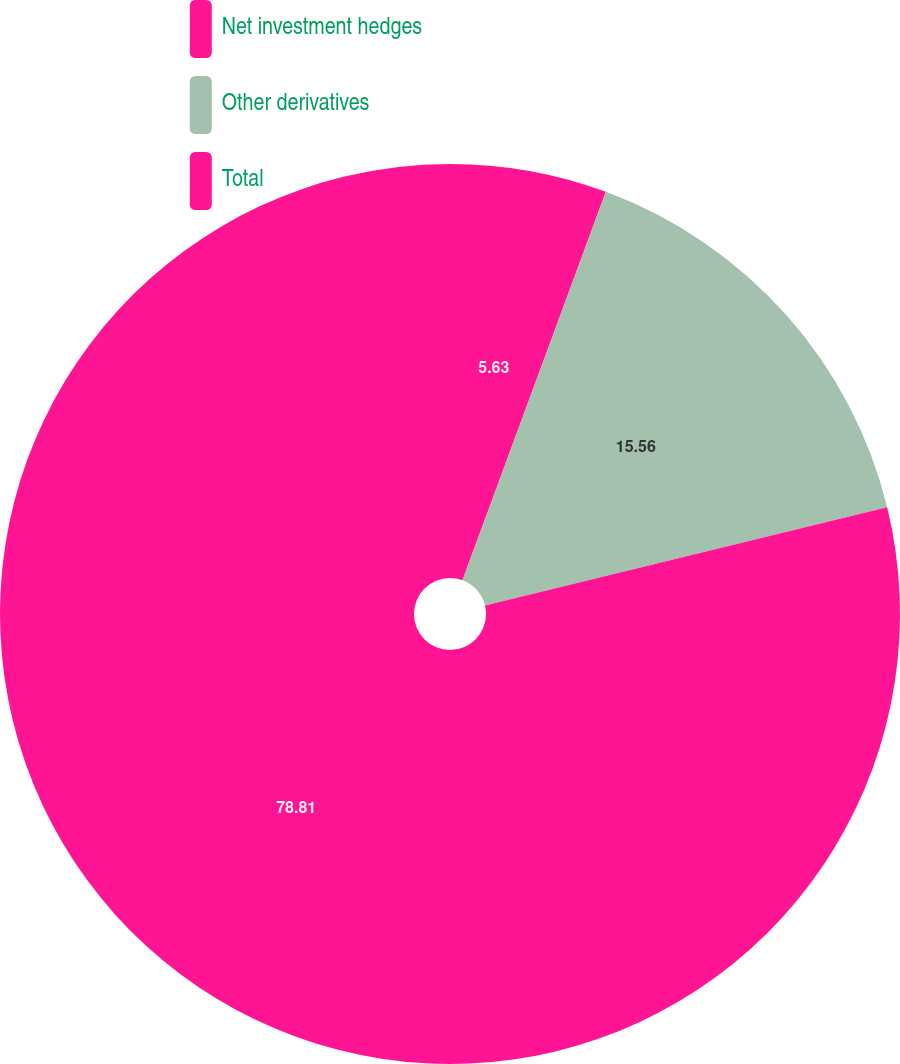<chart> <loc_0><loc_0><loc_500><loc_500><pie_chart><fcel>Net investment hedges<fcel>Other derivatives<fcel>Total<nl><fcel>5.63%<fcel>15.56%<fcel>78.81%<nl></chart> 